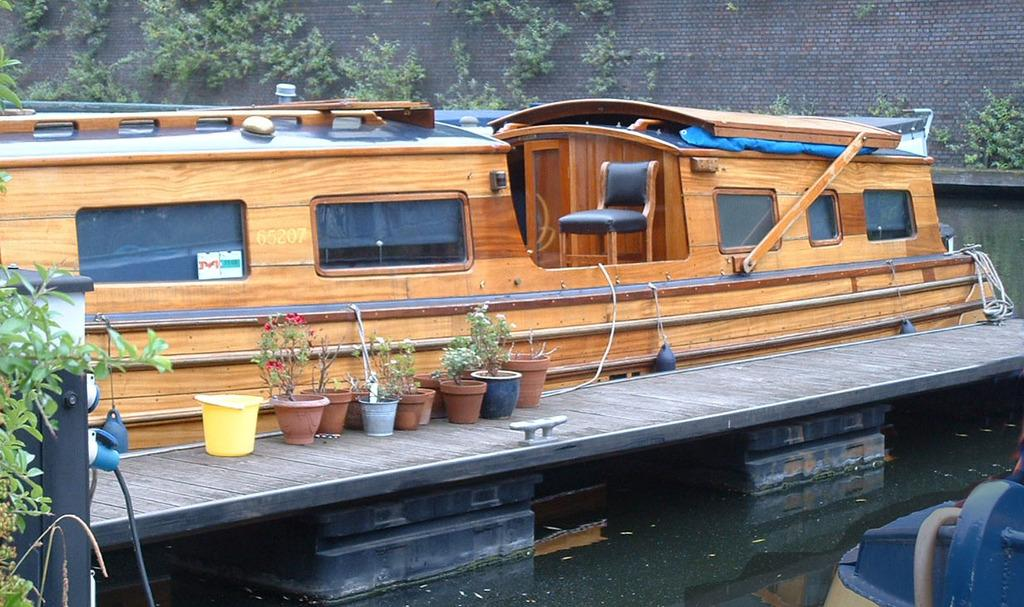What is the main subject of the image? The main subject of the image is a boat. Where is the boat located? The boat is on the water. What other objects can be seen in the image? There are potted plants and trees in the image. What type of tooth can be seen in the image? There is no tooth present in the image. How does the boat affect the mind of the people in the image? The image does not show any people, so it is impossible to determine how the boat affects their minds. 